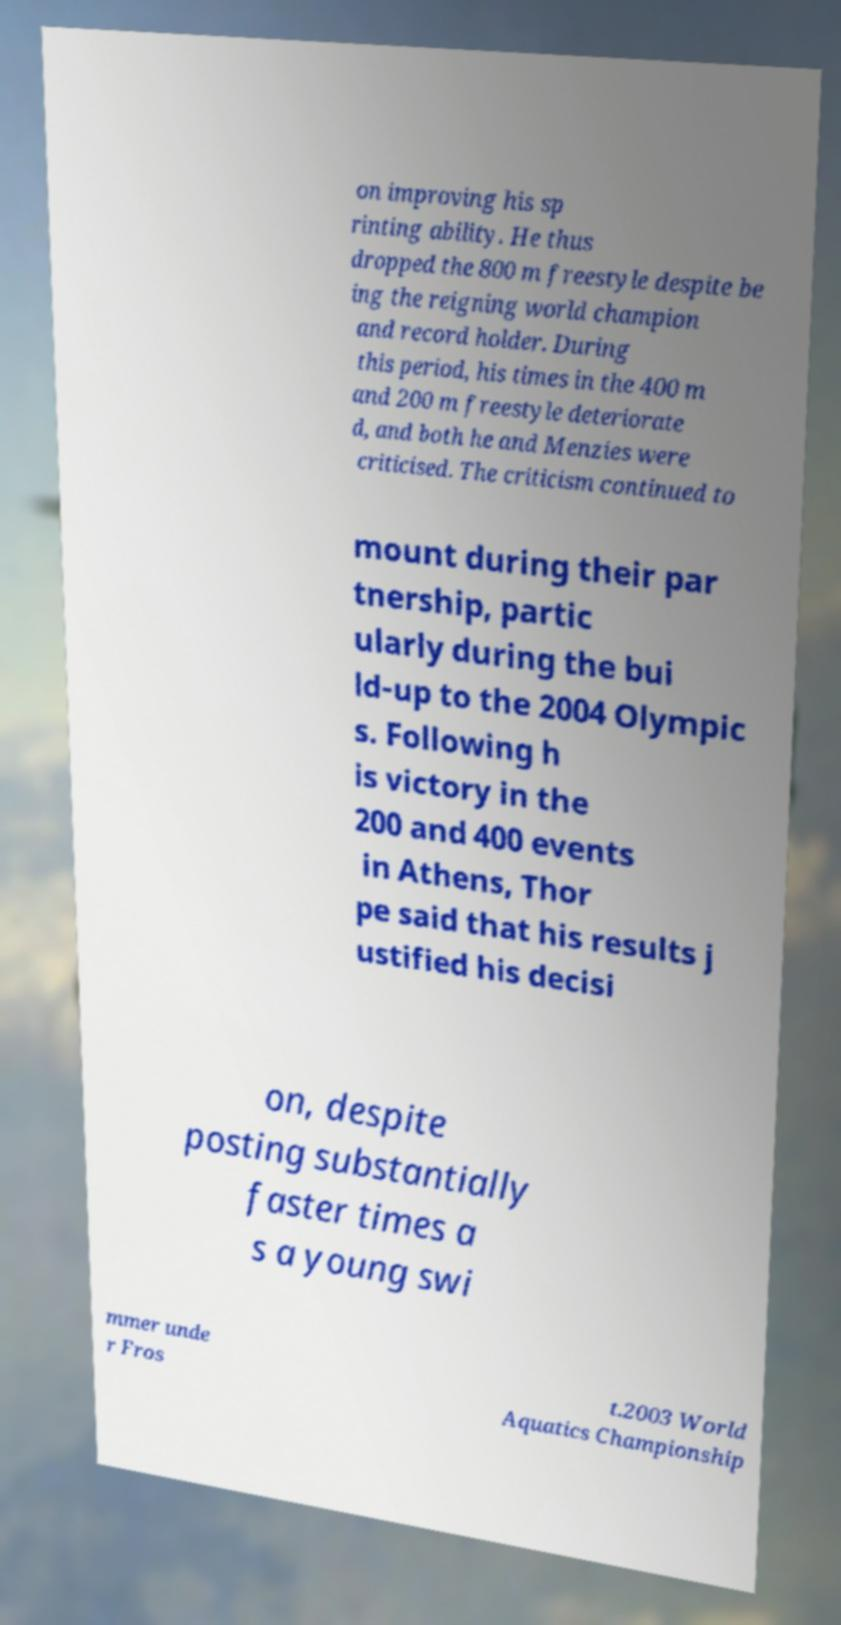Please read and relay the text visible in this image. What does it say? on improving his sp rinting ability. He thus dropped the 800 m freestyle despite be ing the reigning world champion and record holder. During this period, his times in the 400 m and 200 m freestyle deteriorate d, and both he and Menzies were criticised. The criticism continued to mount during their par tnership, partic ularly during the bui ld-up to the 2004 Olympic s. Following h is victory in the 200 and 400 events in Athens, Thor pe said that his results j ustified his decisi on, despite posting substantially faster times a s a young swi mmer unde r Fros t.2003 World Aquatics Championship 